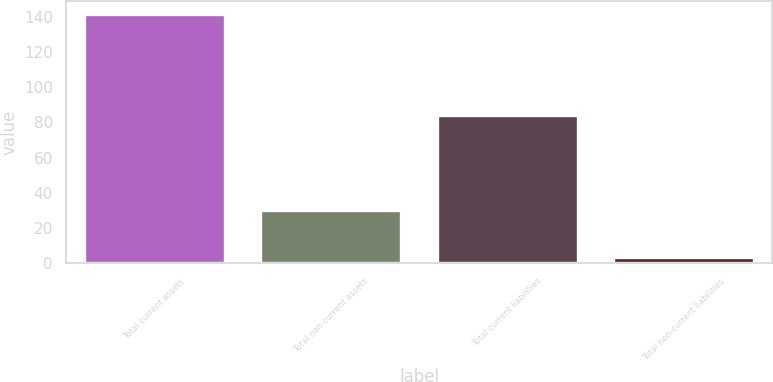Convert chart to OTSL. <chart><loc_0><loc_0><loc_500><loc_500><bar_chart><fcel>Total current assets<fcel>Total non-current assets<fcel>Total current liabilities<fcel>Total non-current liabilities<nl><fcel>141.6<fcel>30.5<fcel>84.3<fcel>3.5<nl></chart> 